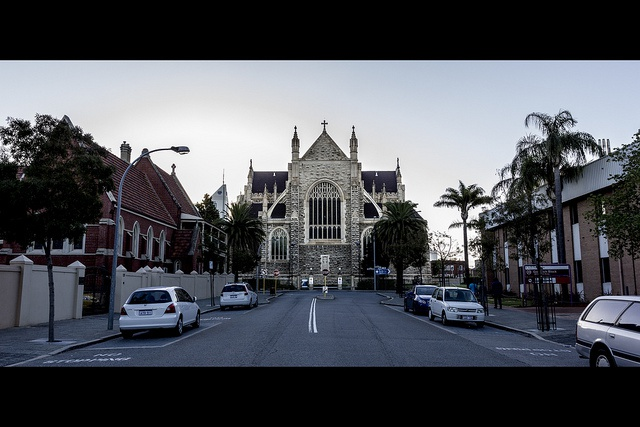Describe the objects in this image and their specific colors. I can see car in black, darkgray, and gray tones, car in black, gray, and darkgray tones, car in black, gray, and darkgray tones, car in black and gray tones, and car in black, navy, darkblue, and gray tones in this image. 